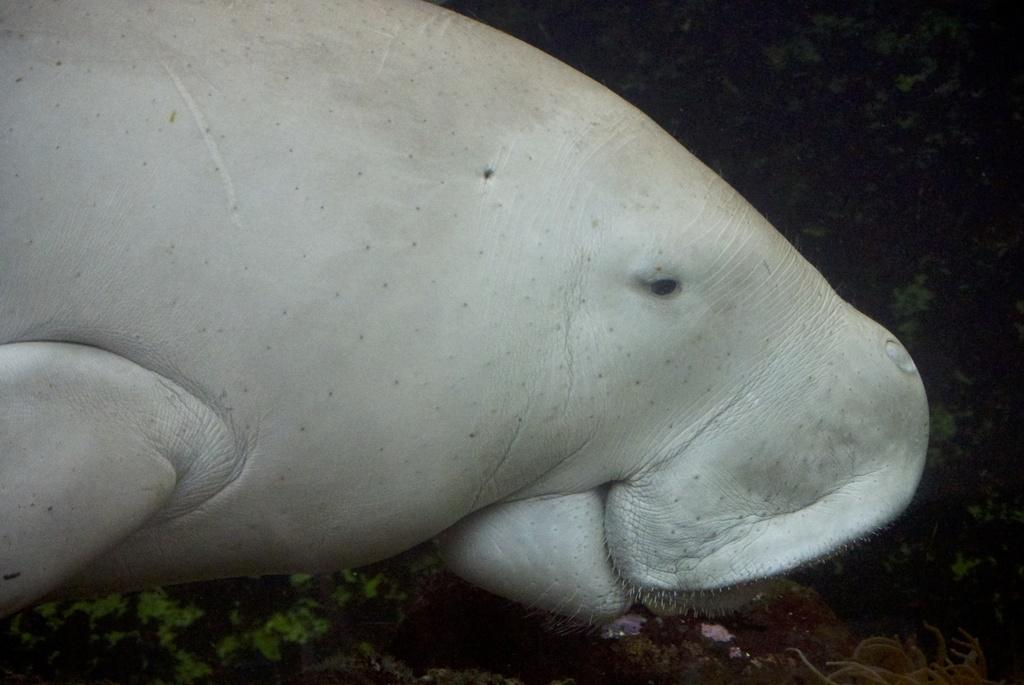What type of animal can be seen in the foreground of the image? There is an aquatic animal in the foreground of the image. Where is the aquatic animal located in relation to the water? The aquatic animal is under the water. What direction is the servant facing in the image? There is no servant present in the image. 